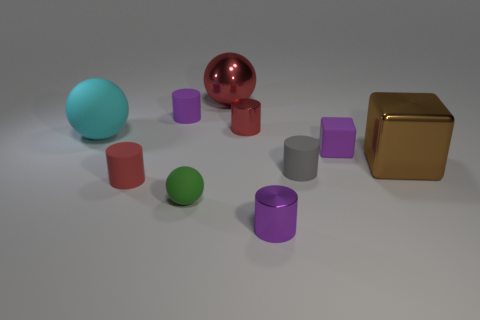Subtract 1 cylinders. How many cylinders are left? 4 Subtract all gray cylinders. Subtract all green balls. How many cylinders are left? 4 Subtract all spheres. How many objects are left? 7 Subtract 1 brown cubes. How many objects are left? 9 Subtract all small shiny objects. Subtract all large blue metallic cylinders. How many objects are left? 8 Add 1 large red metallic objects. How many large red metallic objects are left? 2 Add 7 small brown matte spheres. How many small brown matte spheres exist? 7 